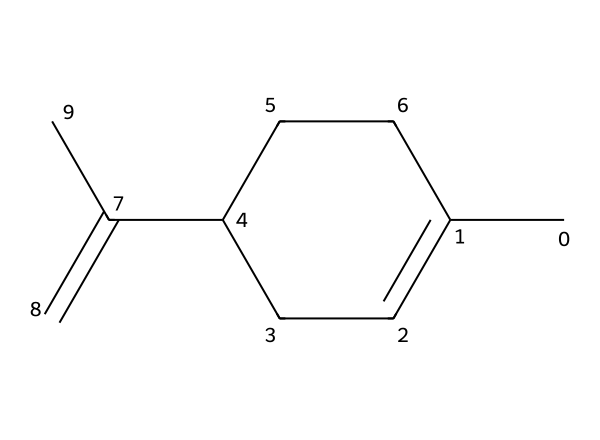What is the molecular formula of limonene? To determine the molecular formula, count the number of carbon (C) and hydrogen (H) atoms in the chemical structure. The structure has 10 carbon atoms and 16 hydrogen atoms. Therefore, the molecular formula is C10H16.
Answer: C10H16 How many rings are present in the structure of limonene? Analyzing the structure shows that there is one ring formed by the carbon atoms, specifically a cyclohexene ring. Therefore, there is 1 ring.
Answer: 1 What type of bond connects the carbon atoms in limonene? In limonene, the carbon atoms are primarily connected by single bonds, with one double bond present (between carbon atoms in the alkene part of the structure). Thus, the predominant bond type is a single bond.
Answer: single bond What is the role of the double bond in limonene? The double bond in limonene (located in the chain outside the ring) allows for reactivity and is characteristic of alkenes, which can participate in addition reactions. This structural feature contributes to the chemical's reactivity.
Answer: reactivity How many double bonds are there in limonene? By examining the structure, you can see that there is one double bond in the molecule. Counting the double-bonded connections confirms this observation. Therefore, limonene has one double bond.
Answer: 1 What type of terpene is limonene classified as? Limonene is classified as a monoterpene because it consists of two isoprene units (10 carbon atoms). This classification is based on its molecular structure, which fits the definition of a monoterpene.
Answer: monoterpene 